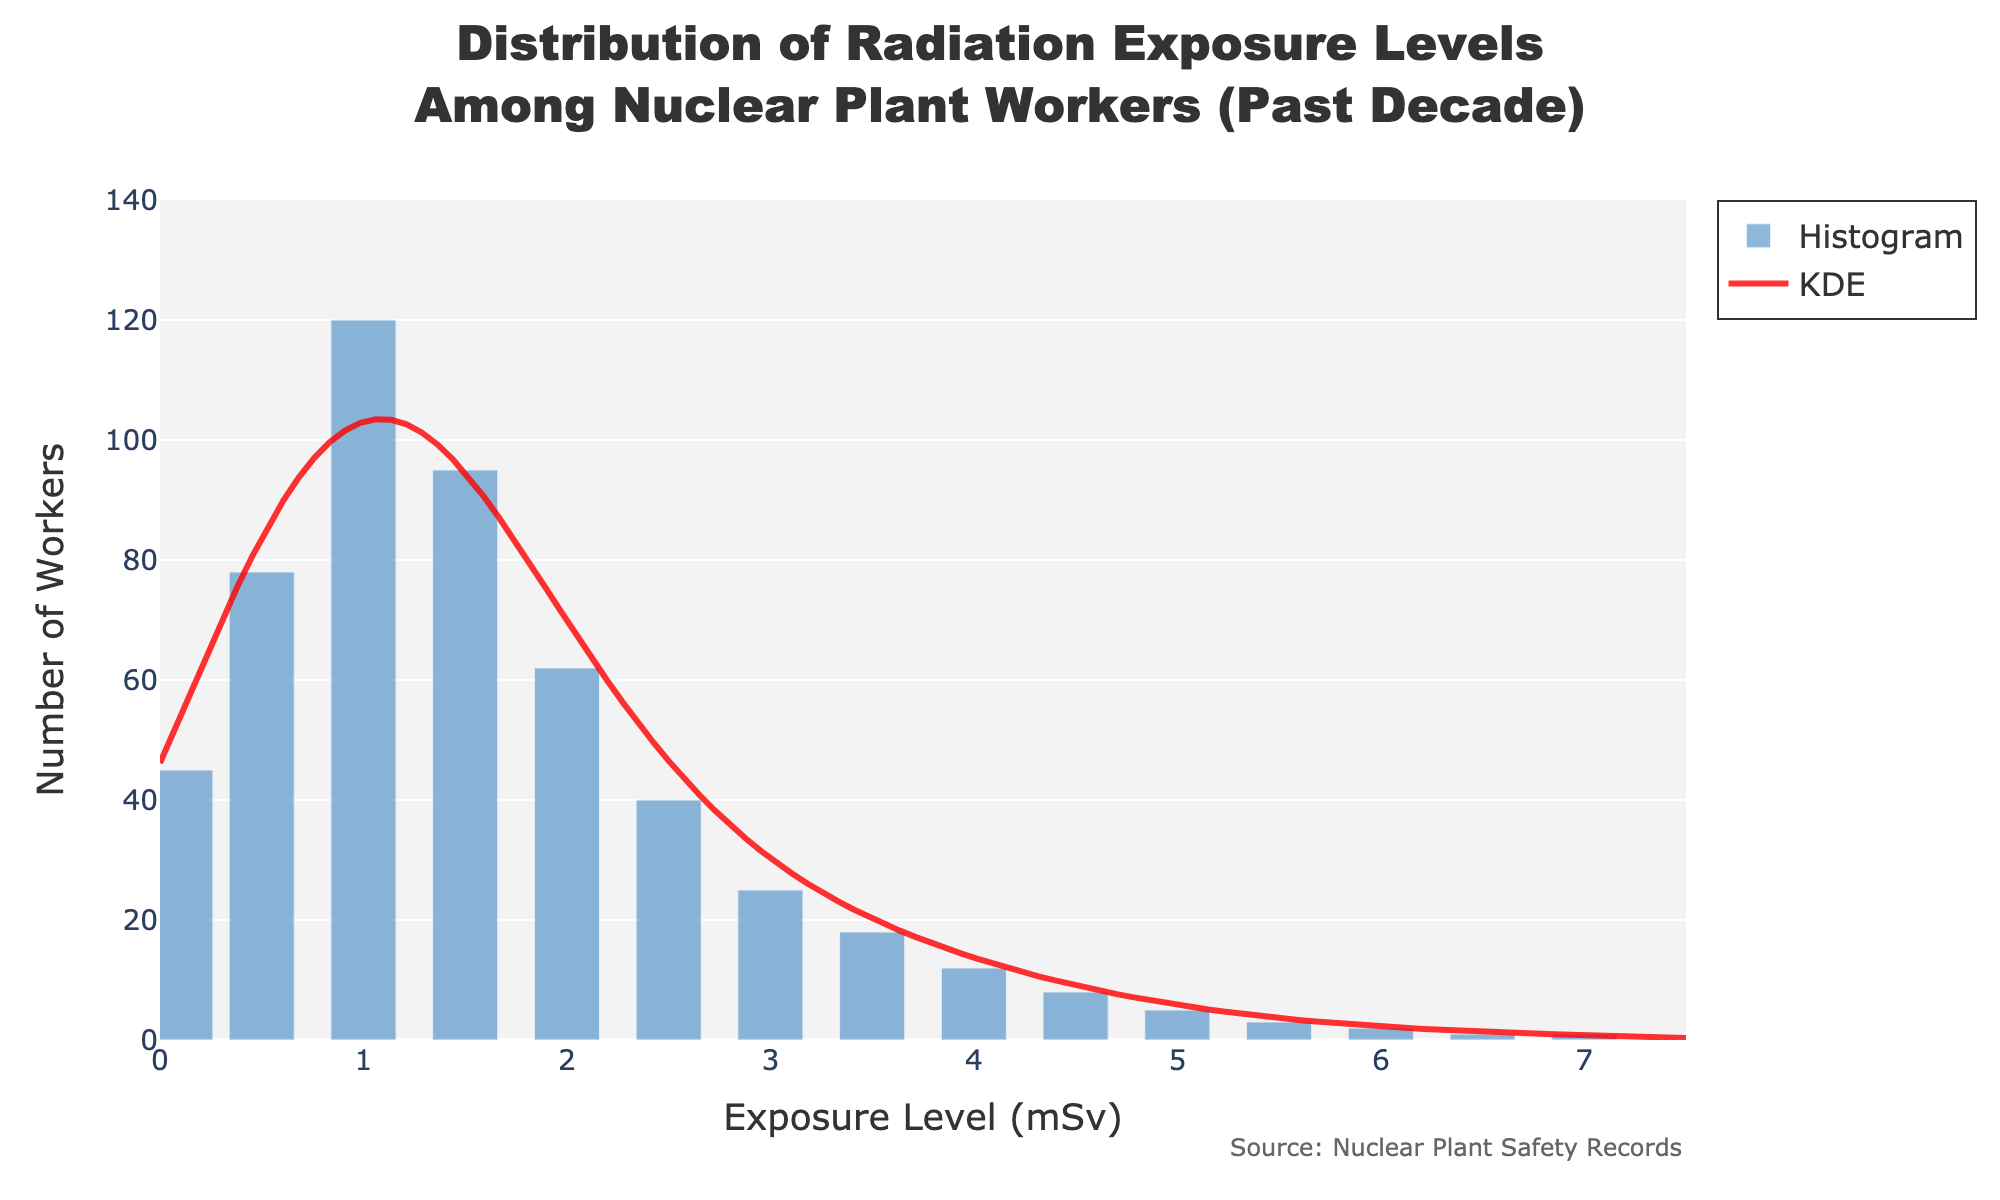What is the title of the figure? The title of the figure is displayed at the top and reads "Distribution of Radiation Exposure Levels Among Nuclear Plant Workers (Past Decade)".
Answer: Distribution of Radiation Exposure Levels Among Nuclear Plant Workers (Past Decade) What do the x-axis and y-axis represent? The x-axis represents the "Exposure Level (mSv)", measuring the radiation exposure in millisieverts, and the y-axis represents the "Number of Workers", indicating the count of workers for each exposure level.
Answer: Exposure Level (mSv), Number of Workers What color is used for the histogram bars and the KDE curve? The histogram bars are colored in a blue shade and the KDE curve is colored in red.
Answer: Blue, Red Which exposure level has the highest count of workers and what is that count? The highest count of workers is at the exposure level of 1.0 mSv, with a count of 120 workers.
Answer: 1.0 mSv, 120 How does the count of workers change as the exposure level increases from 1.0 mSv to 2.0 mSv? The count of workers decreases as the exposure level increases; it goes from 120 at 1.0 mSv to 95 at 1.5 mSv and then to 62 at 2.0 mSv.
Answer: Decreases What is the sum of workers exposed to levels between 0.1 mSv and 1.5 mSv? Add the count of workers at each of the exposure levels from 0.1 mSv to 1.5 mSv: 45 (0.1 mSv) + 78 (0.5 mSv) + 120 (1.0 mSv) + 95 (1.5 mSv) = 338 workers.
Answer: 338 How many workers were exposed to radiation levels above 3.0 mSv? Sum the counts of workers at exposure levels above 3.0 mSv: 18 (3.5 mSv) + 12 (4.0 mSv) + 8 (4.5 mSv) + 5 (5.0 mSv) + 3 (5.5 mSv) + 2 (6.0 mSv) + 1 (6.5 mSv) + 1 (7.0 mSv) = 50 workers.
Answer: 50 What is the average number of workers exposed across all exposure levels given in the data? Sum all worker counts and divide by the number of exposure levels: (45 + 78 + 120 + 95 + 62 + 40 + 25 + 18 + 12 + 8 + 5 + 3 + 2 + 1 + 1) / 15 ≈ 34.
Answer: ~34 Explain the shape of the KDE curve in relation to the histogram. The KDE curve is smooth and reflects the density of the histogram data points. The peak of the KDE corresponds to the exposure level with the highest count (1.0 mSv), and it decreases as the exposure levels move away from this peak, indicating fewer workers at higher and lower exposure levels.
Answer: Smooth with a peak at 1.0 mSv How does the number of workers exposed to 1.0 mSv compare to the sum of workers exposed to levels 2.0 mSv and above? The number of workers exposed to 1.0 mSv is 120. Sum the number of workers for levels 2.0 mSv and above: (62 + 40 + 25 + 18 + 12 + 8 + 5 + 3 + 2 + 1 + 1) = 177. Comparing them, 177 > 120.
Answer: 177 > 120 